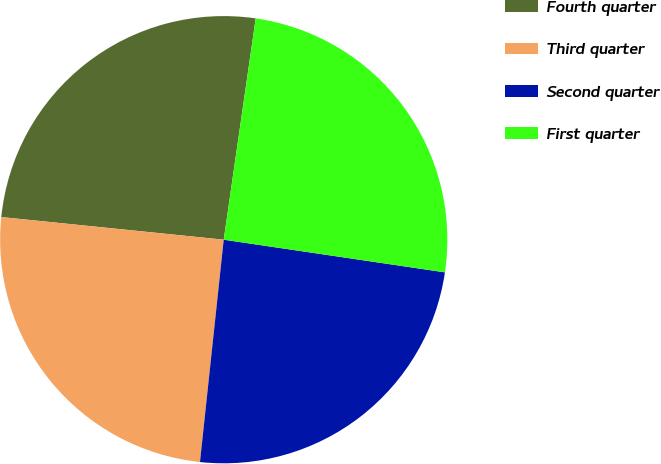Convert chart to OTSL. <chart><loc_0><loc_0><loc_500><loc_500><pie_chart><fcel>Fourth quarter<fcel>Third quarter<fcel>Second quarter<fcel>First quarter<nl><fcel>25.67%<fcel>24.92%<fcel>24.36%<fcel>25.05%<nl></chart> 